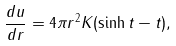<formula> <loc_0><loc_0><loc_500><loc_500>\frac { d u } { d r } = 4 \pi r ^ { 2 } K ( \sinh t - t ) ,</formula> 